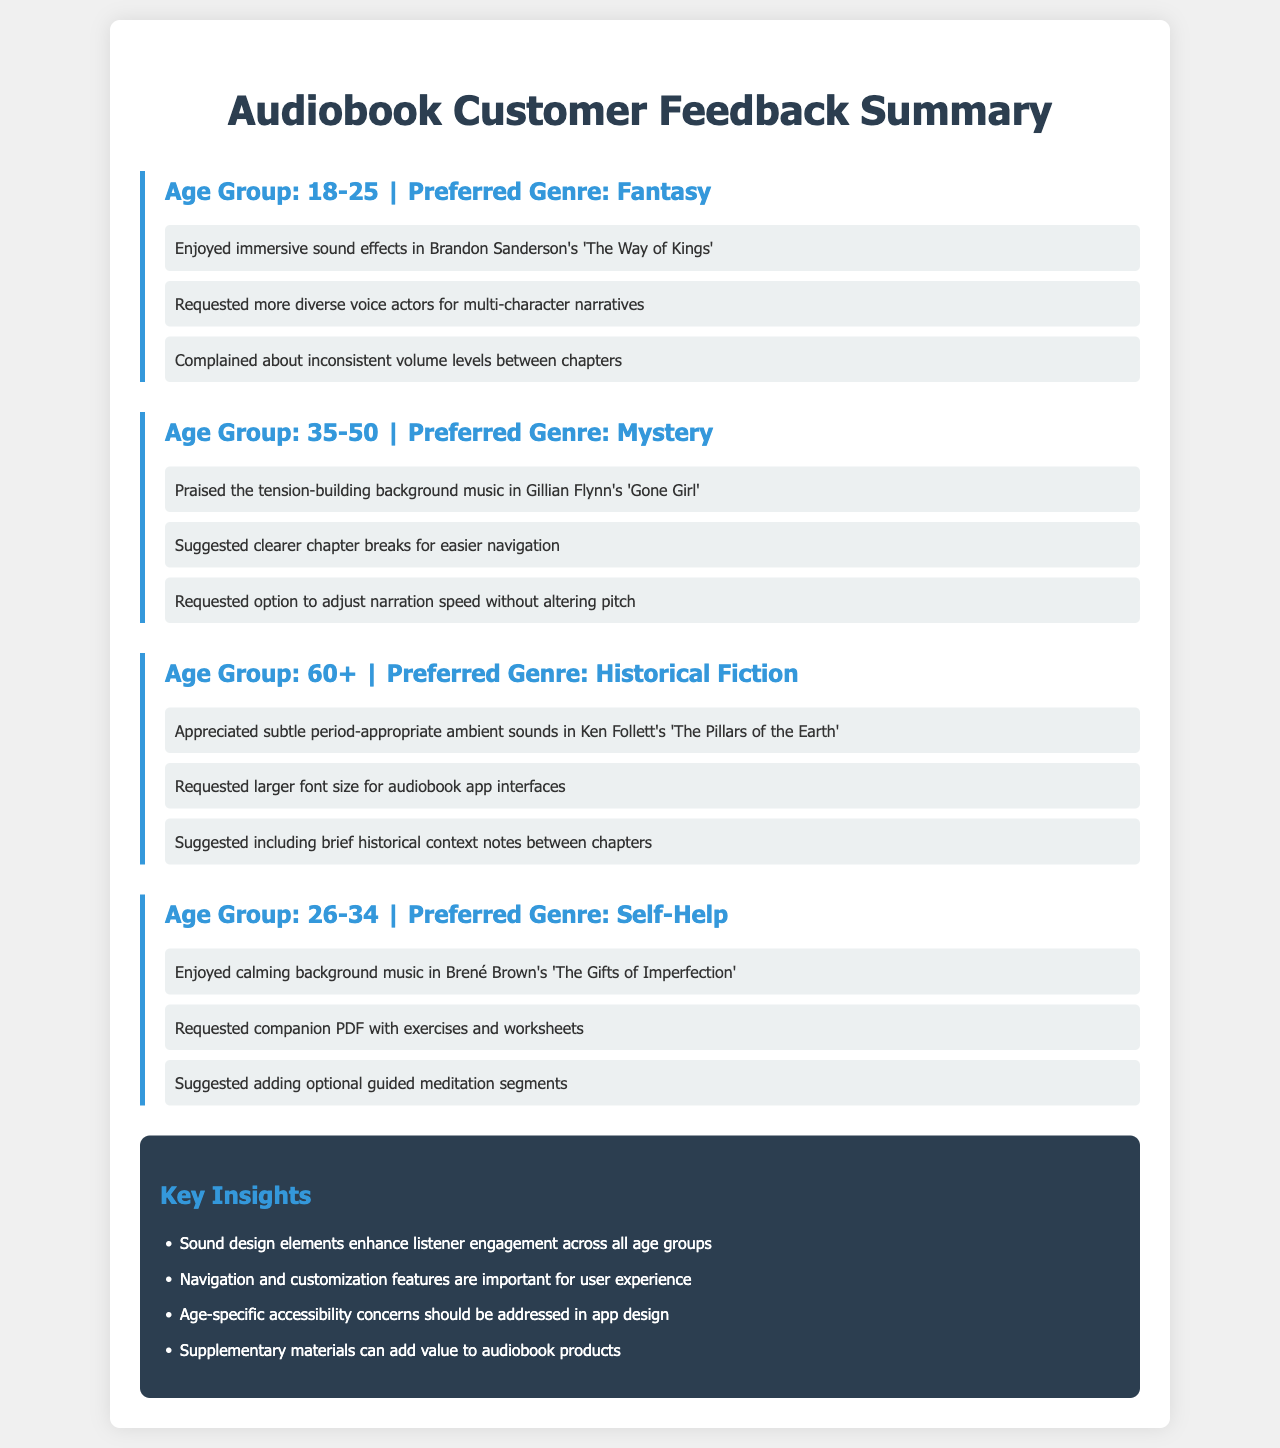What age group preferred the Fantasy genre? The document lists the feedback for the Fantasy genre under the age group 18-25.
Answer: 18-25 What feature was requested for audiobook app interfaces by the 60+ age group? The feedback indicates a request for larger font size for audiobook app interfaces from the 60+ age group.
Answer: Larger font size Which audiobook received praise for its tension-building background music? The feedback mentions Gillian Flynn's 'Gone Girl' in relation to praised background music.
Answer: 'Gone Girl' What did the 26-34 age group suggest adding to audiobooks? The 26-34 age group suggested adding optional guided meditation segments to audiobooks.
Answer: Guided meditation segments How many key insights are listed in the document? The document contains four key insights in the listed section.
Answer: 4 What genre did the 35-50 age group prefer? The preferred genre for the 35-50 age group listed in the document is Mystery.
Answer: Mystery What type of sound design element did the 60+ age group appreciate? The feedback shows that the 60+ age group appreciated subtle period-appropriate ambient sounds.
Answer: Ambient sounds What was a common request from multiple age groups regarding audiobooks? The feedback reveals that multiple age groups requested features for clearer navigation.
Answer: Clearer navigation What complimentary material did the 26-34 age group want alongside the audiobook? They requested a companion PDF with exercises and worksheets as complimentary material.
Answer: Companion PDF 